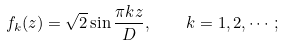<formula> <loc_0><loc_0><loc_500><loc_500>f _ { k } ( z ) = \sqrt { 2 } \sin \frac { \pi k z } { D } , \quad k = 1 , 2 , \cdots ;</formula> 